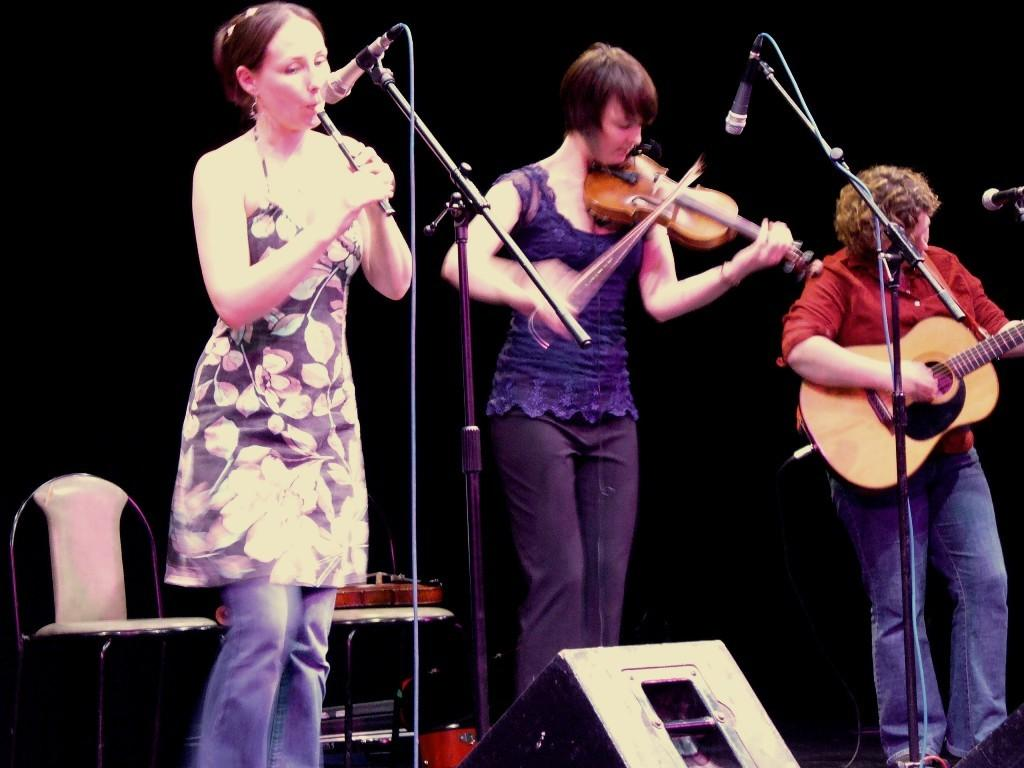How many people are present in the image? There are three people in the image. What objects are present in the image that are related to sound? There are microphones in the image. What other items can be seen in the image? There are musical instruments in the image. Can you describe the background of the image? The background of the image is dark. What might the people in the image be doing based on the presence of microphones and musical instruments? The people in the image might be performing or recording music. In which direction are the men in the image facing? There is no mention of the gender of the people in the image, and the direction they are facing is not specified. 